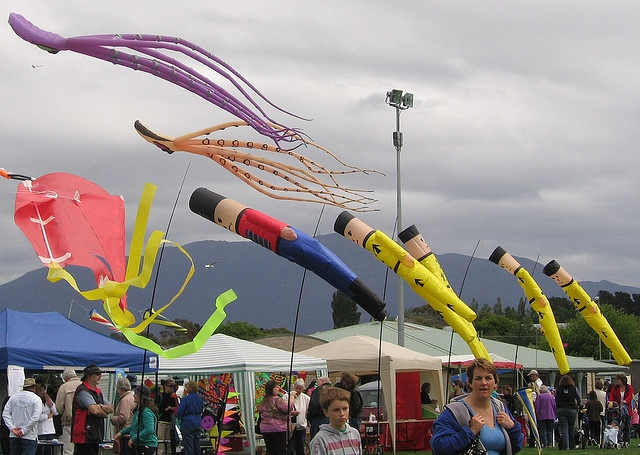Describe the objects in this image and their specific colors. I can see kite in lightgray, salmon, gray, olive, and darkgray tones, kite in lightgray and purple tones, people in lightgray, black, gray, and maroon tones, kite in lightgray, darkgray, salmon, and tan tones, and kite in lightgray, black, brown, gray, and navy tones in this image. 